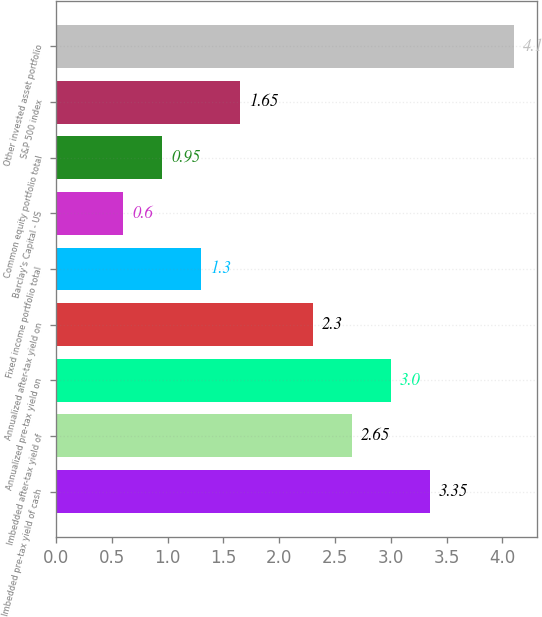Convert chart to OTSL. <chart><loc_0><loc_0><loc_500><loc_500><bar_chart><fcel>Imbedded pre-tax yield of cash<fcel>Imbedded after-tax yield of<fcel>Annualized pre-tax yield on<fcel>Annualized after-tax yield on<fcel>Fixed income portfolio total<fcel>Barclay's Capital - US<fcel>Common equity portfolio total<fcel>S&P 500 index<fcel>Other invested asset portfolio<nl><fcel>3.35<fcel>2.65<fcel>3<fcel>2.3<fcel>1.3<fcel>0.6<fcel>0.95<fcel>1.65<fcel>4.1<nl></chart> 